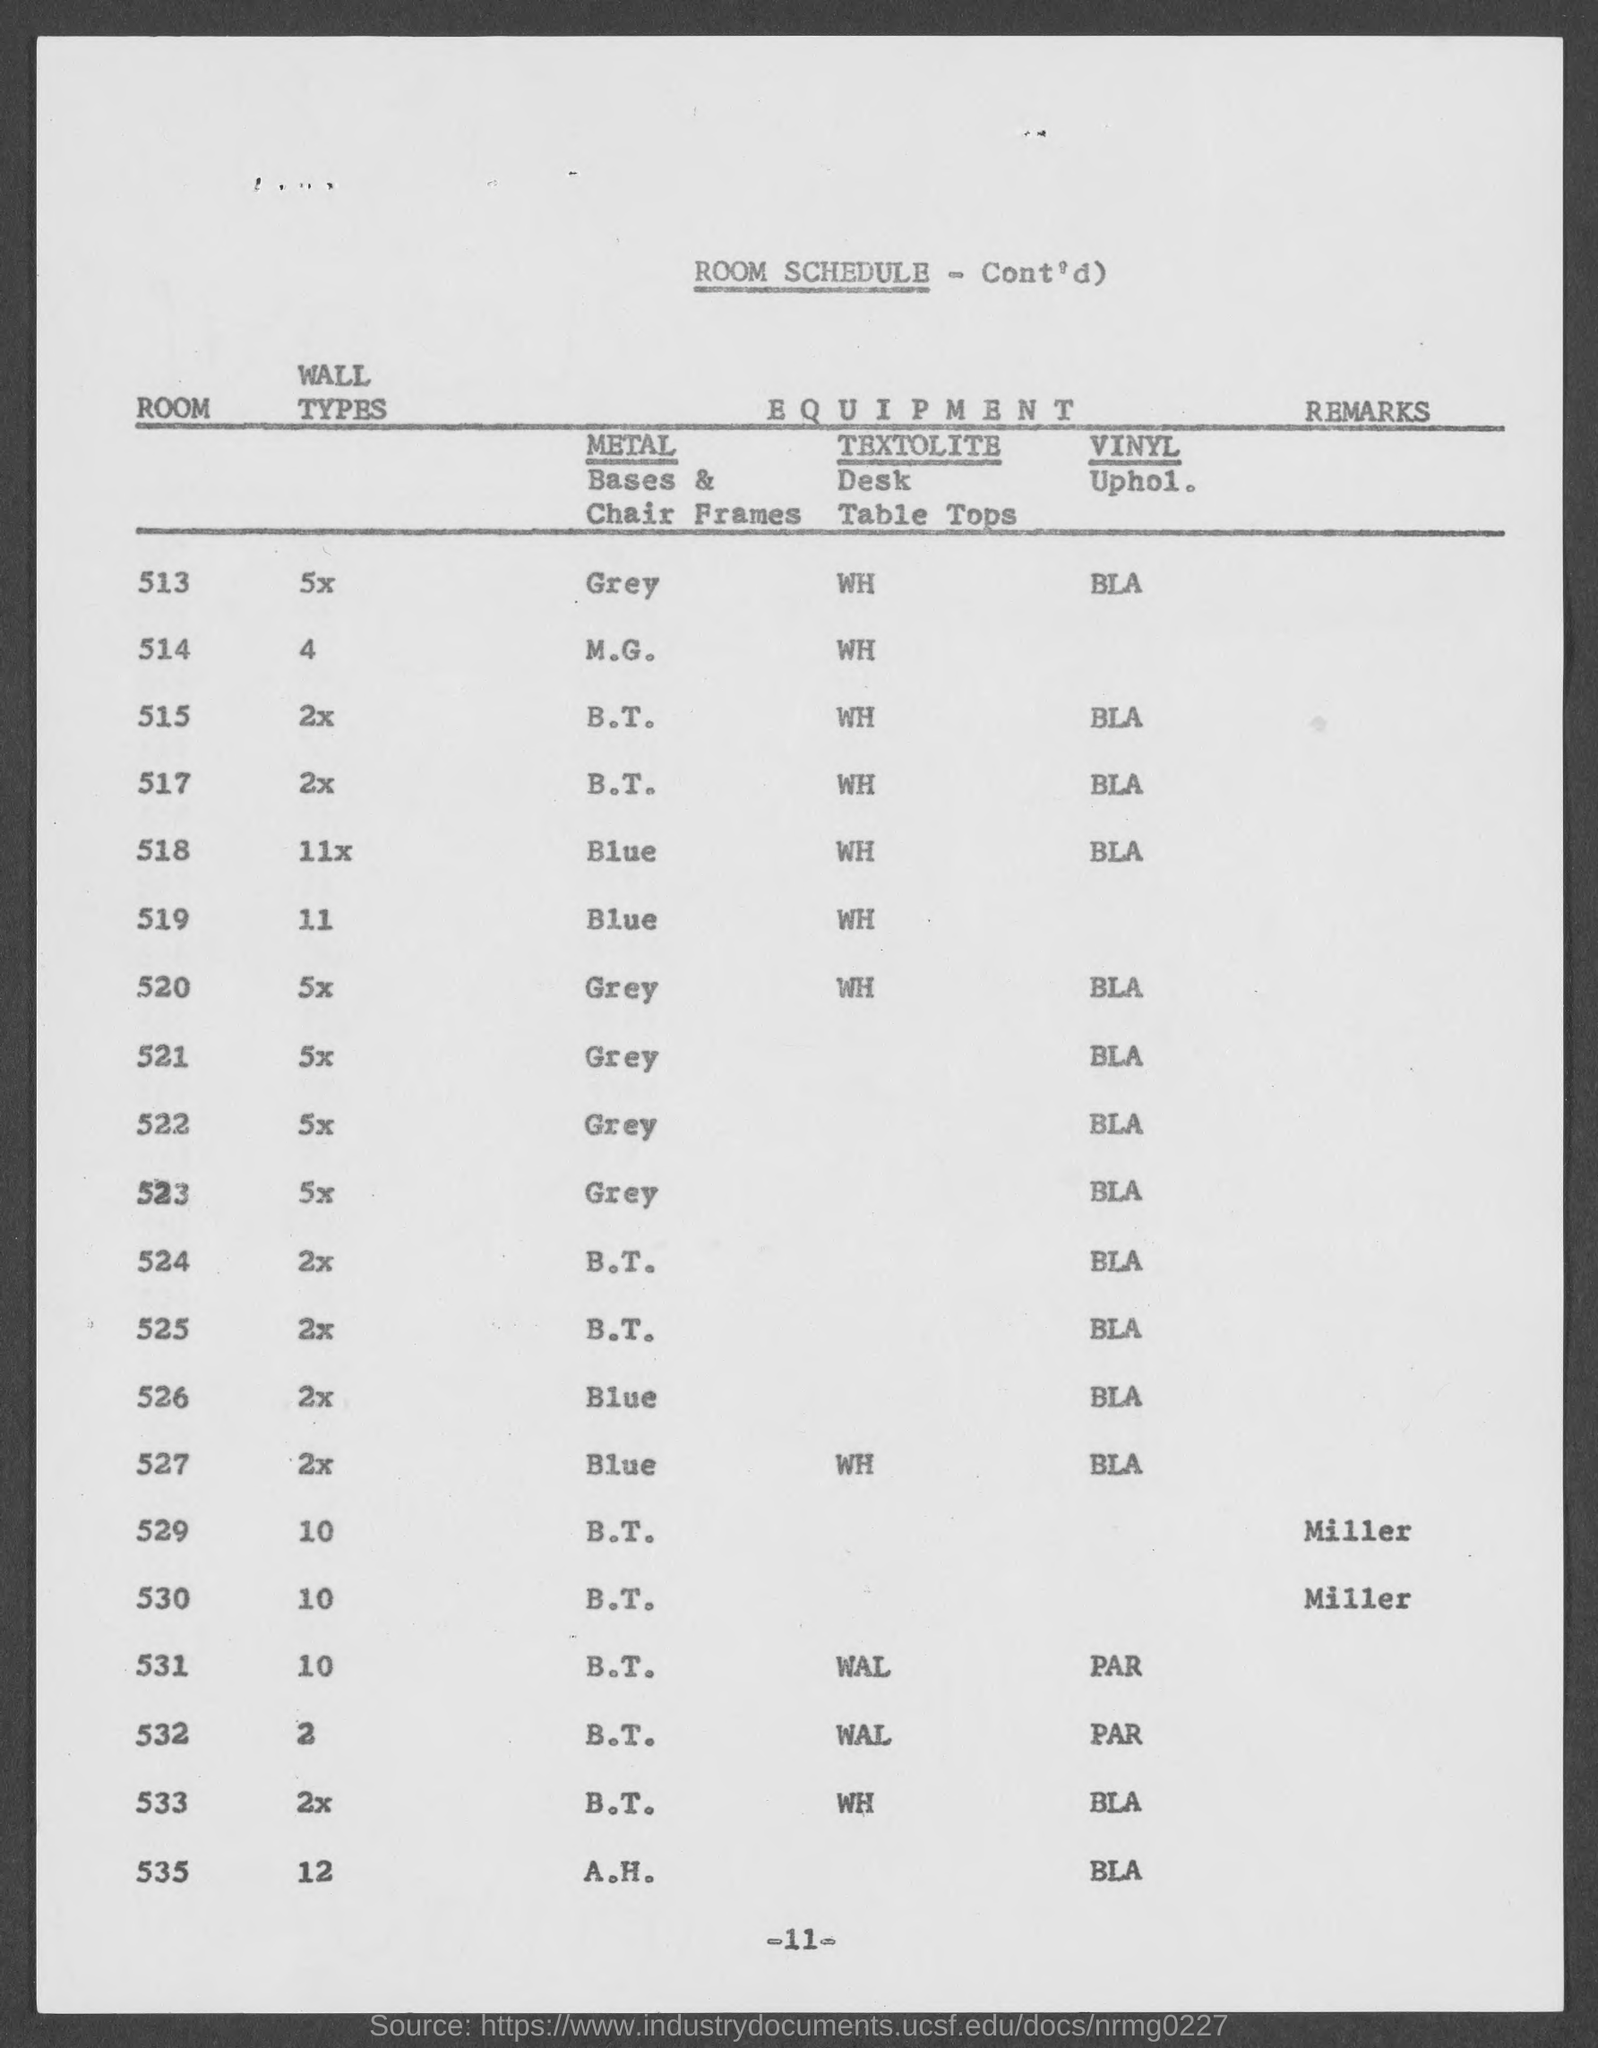Indicate a few pertinent items in this graphic. This document pertains to a room schedule. Miller has given the remarks. 